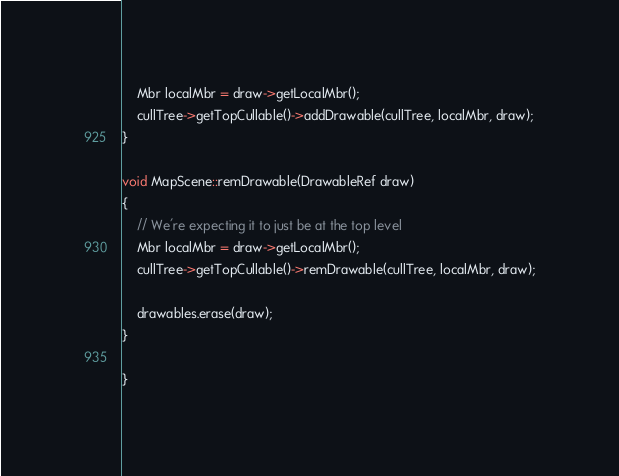Convert code to text. <code><loc_0><loc_0><loc_500><loc_500><_ObjectiveC_>    Mbr localMbr = draw->getLocalMbr();
    cullTree->getTopCullable()->addDrawable(cullTree, localMbr, draw);
}

void MapScene::remDrawable(DrawableRef draw)
{
    // We're expecting it to just be at the top level
    Mbr localMbr = draw->getLocalMbr();
    cullTree->getTopCullable()->remDrawable(cullTree, localMbr, draw);
    
    drawables.erase(draw);
}
    
}
</code> 